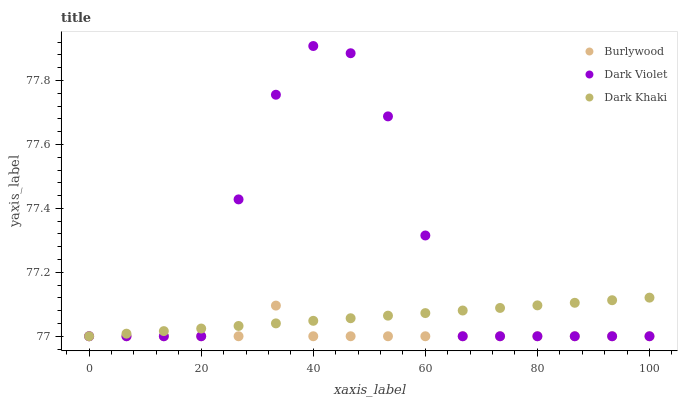Does Burlywood have the minimum area under the curve?
Answer yes or no. Yes. Does Dark Violet have the maximum area under the curve?
Answer yes or no. Yes. Does Dark Khaki have the minimum area under the curve?
Answer yes or no. No. Does Dark Khaki have the maximum area under the curve?
Answer yes or no. No. Is Dark Khaki the smoothest?
Answer yes or no. Yes. Is Dark Violet the roughest?
Answer yes or no. Yes. Is Dark Violet the smoothest?
Answer yes or no. No. Is Dark Khaki the roughest?
Answer yes or no. No. Does Burlywood have the lowest value?
Answer yes or no. Yes. Does Dark Violet have the highest value?
Answer yes or no. Yes. Does Dark Khaki have the highest value?
Answer yes or no. No. Does Dark Violet intersect Dark Khaki?
Answer yes or no. Yes. Is Dark Violet less than Dark Khaki?
Answer yes or no. No. Is Dark Violet greater than Dark Khaki?
Answer yes or no. No. 